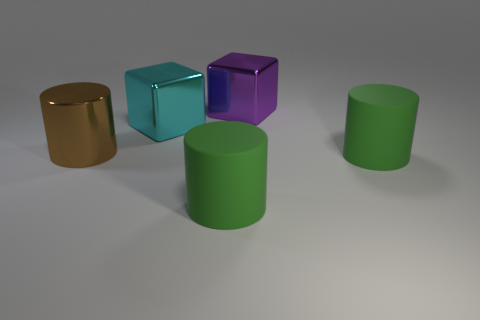What number of objects are big purple blocks or small red rubber spheres?
Ensure brevity in your answer.  1. Is the large purple thing the same shape as the large cyan metal thing?
Provide a succinct answer. Yes. Is there a large cylinder made of the same material as the cyan cube?
Make the answer very short. Yes. There is a rubber thing on the left side of the purple thing; are there any brown things to the right of it?
Offer a very short reply. No. There is a metallic thing to the right of the cyan object; is it the same size as the big brown shiny thing?
Keep it short and to the point. Yes. The brown metal cylinder has what size?
Ensure brevity in your answer.  Large. Are there any metallic things that have the same color as the large metal cylinder?
Your answer should be compact. No. What number of small things are either purple metallic objects or brown metallic things?
Your response must be concise. 0. What size is the thing that is to the right of the large cyan metallic thing and behind the brown object?
Keep it short and to the point. Large. What number of large things are behind the big purple metallic object?
Give a very brief answer. 0. 